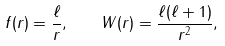Convert formula to latex. <formula><loc_0><loc_0><loc_500><loc_500>f ( r ) = \frac { \ell } { r } , \quad W ( r ) = \frac { \ell ( \ell + 1 ) } { r ^ { 2 } } ,</formula> 